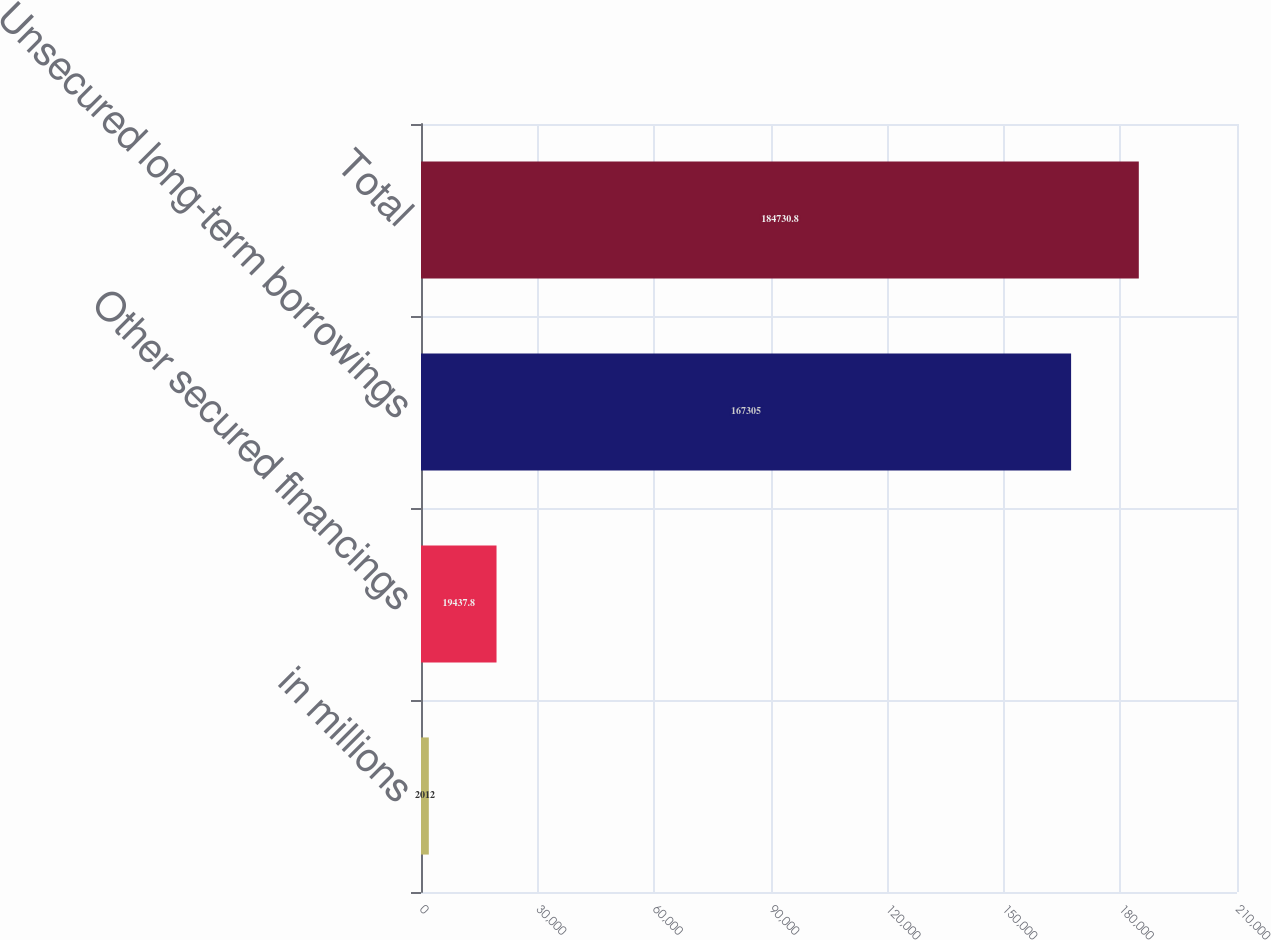Convert chart to OTSL. <chart><loc_0><loc_0><loc_500><loc_500><bar_chart><fcel>in millions<fcel>Other secured financings<fcel>Unsecured long-term borrowings<fcel>Total<nl><fcel>2012<fcel>19437.8<fcel>167305<fcel>184731<nl></chart> 